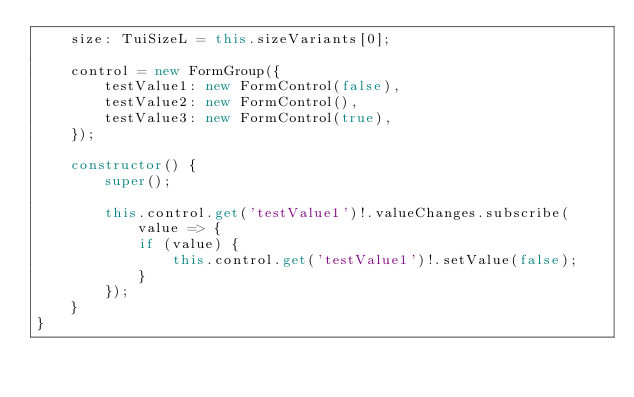<code> <loc_0><loc_0><loc_500><loc_500><_TypeScript_>    size: TuiSizeL = this.sizeVariants[0];

    control = new FormGroup({
        testValue1: new FormControl(false),
        testValue2: new FormControl(),
        testValue3: new FormControl(true),
    });

    constructor() {
        super();

        this.control.get('testValue1')!.valueChanges.subscribe(value => {
            if (value) {
                this.control.get('testValue1')!.setValue(false);
            }
        });
    }
}
</code> 